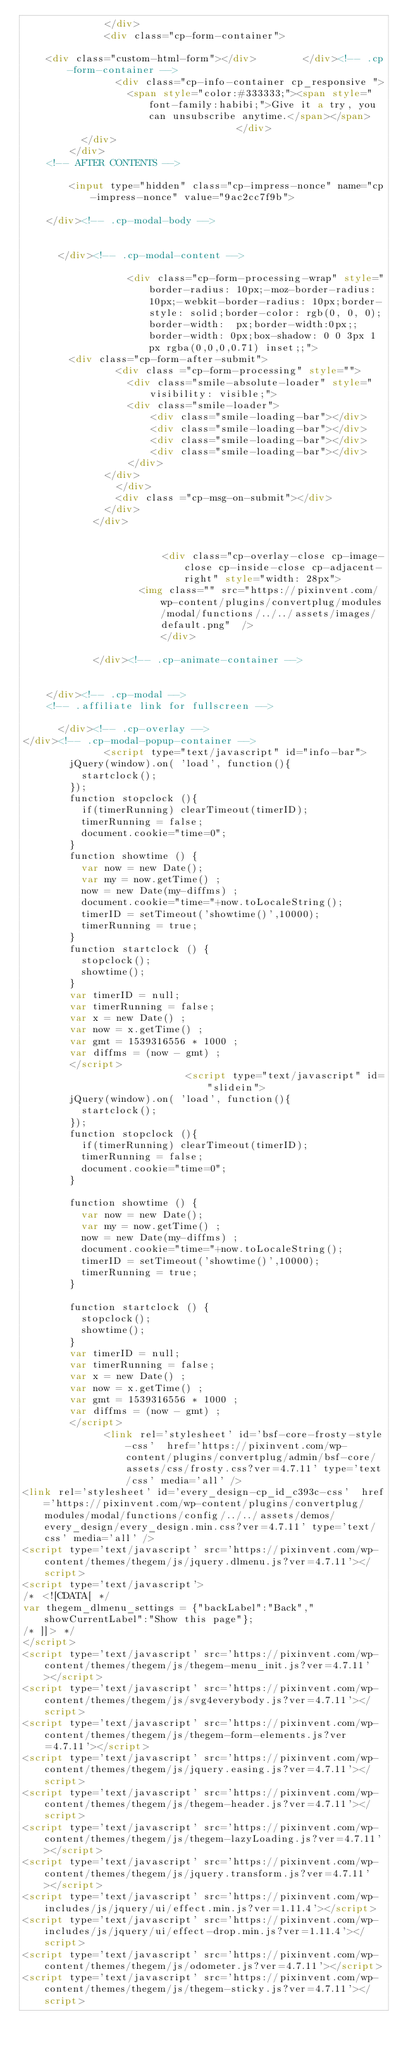Convert code to text. <code><loc_0><loc_0><loc_500><loc_500><_HTML_>          		</div>
          		<div class="cp-form-container">
					
		<div class="custom-html-form"></div>				</div><!-- .cp-form-container -->
                <div class="cp-info-container cp_responsive ">
                	<span style="color:#333333;"><span style="font-family:habibi;">Give it a try, you can unsubscribe anytime.</span></span>                </div>
      		</div>
      	</div>
		<!-- AFTER CONTENTS -->
			
				<input type="hidden" class="cp-impress-nonce" name="cp-impress-nonce" value="9ac2cc7f9b">

		</div><!-- .cp-modal-body -->

		
			</div><!-- .cp-modal-content -->
			
            			<div class="cp-form-processing-wrap" style="border-radius: 10px;-moz-border-radius: 10px;-webkit-border-radius: 10px;border-style: solid;border-color: rgb(0, 0, 0);border-width:  px;border-width:0px;;border-width: 0px;box-shadow: 0 0 3px 1px rgba(0,0,0,0.71) inset;;">
				<div class="cp-form-after-submit">
            		<div class ="cp-form-processing" style="">
            			<div class="smile-absolute-loader" style="visibility: visible;">
					        <div class="smile-loader">
					            <div class="smile-loading-bar"></div>
					            <div class="smile-loading-bar"></div>
					            <div class="smile-loading-bar"></div>
					            <div class="smile-loading-bar"></div>
					        </div>
					    </div>
            		</div>
            		<div class ="cp-msg-on-submit"></div>
            	</div>
            </div>
            
    		
	      				      	<div class="cp-overlay-close cp-image-close cp-inside-close cp-adjacent-right" style="width: 28px">
										<img class="" src="https://pixinvent.com/wp-content/plugins/convertplug/modules/modal/functions/../../assets/images/default.png"  />							      	</div>

		    		</div><!-- .cp-animate-container -->

		
    </div><!-- .cp-modal -->
		<!-- .affiliate link for fullscreen -->

			</div><!-- .cp-overlay -->
</div><!-- .cp-modal-popup-container -->
	            <script type="text/javascript" id="info-bar">
				jQuery(window).on( 'load', function(){
					startclock();
				});
				function stopclock (){
				  if(timerRunning) clearTimeout(timerID);
				  timerRunning = false;
				  document.cookie="time=0";
				}
				function showtime () {
				  var now = new Date();
				  var my = now.getTime() ;
				  now = new Date(my-diffms) ;
				  document.cookie="time="+now.toLocaleString();
				  timerID = setTimeout('showtime()',10000);
				  timerRunning = true;
				}
				function startclock () {
				  stopclock();
				  showtime();
				}
				var timerID = null;
				var timerRunning = false;
				var x = new Date() ;
				var now = x.getTime() ;
				var gmt = 1539316556 * 1000 ;
				var diffms = (now - gmt) ;
				</script>
	            	            <script type="text/javascript" id="slidein">
				jQuery(window).on( 'load', function(){
					startclock();
				});
				function stopclock (){
				  if(timerRunning) clearTimeout(timerID);
				  timerRunning = false;
				  document.cookie="time=0";
				}

				function showtime () {
				  var now = new Date();
				  var my = now.getTime() ;
				  now = new Date(my-diffms) ;
				  document.cookie="time="+now.toLocaleString();
				  timerID = setTimeout('showtime()',10000);
				  timerRunning = true;
				}

				function startclock () {
				  stopclock();
				  showtime();
				}
				var timerID = null;
				var timerRunning = false;
				var x = new Date() ;
				var now = x.getTime() ;
				var gmt = 1539316556 * 1000 ;
				var diffms = (now - gmt) ;
				</script>
	            <link rel='stylesheet' id='bsf-core-frosty-style-css'  href='https://pixinvent.com/wp-content/plugins/convertplug/admin/bsf-core/assets/css/frosty.css?ver=4.7.11' type='text/css' media='all' />
<link rel='stylesheet' id='every_design-cp_id_c393c-css'  href='https://pixinvent.com/wp-content/plugins/convertplug/modules/modal/functions/config/../../assets/demos/every_design/every_design.min.css?ver=4.7.11' type='text/css' media='all' />
<script type='text/javascript' src='https://pixinvent.com/wp-content/themes/thegem/js/jquery.dlmenu.js?ver=4.7.11'></script>
<script type='text/javascript'>
/* <![CDATA[ */
var thegem_dlmenu_settings = {"backLabel":"Back","showCurrentLabel":"Show this page"};
/* ]]> */
</script>
<script type='text/javascript' src='https://pixinvent.com/wp-content/themes/thegem/js/thegem-menu_init.js?ver=4.7.11'></script>
<script type='text/javascript' src='https://pixinvent.com/wp-content/themes/thegem/js/svg4everybody.js?ver=4.7.11'></script>
<script type='text/javascript' src='https://pixinvent.com/wp-content/themes/thegem/js/thegem-form-elements.js?ver=4.7.11'></script>
<script type='text/javascript' src='https://pixinvent.com/wp-content/themes/thegem/js/jquery.easing.js?ver=4.7.11'></script>
<script type='text/javascript' src='https://pixinvent.com/wp-content/themes/thegem/js/thegem-header.js?ver=4.7.11'></script>
<script type='text/javascript' src='https://pixinvent.com/wp-content/themes/thegem/js/thegem-lazyLoading.js?ver=4.7.11'></script>
<script type='text/javascript' src='https://pixinvent.com/wp-content/themes/thegem/js/jquery.transform.js?ver=4.7.11'></script>
<script type='text/javascript' src='https://pixinvent.com/wp-includes/js/jquery/ui/effect.min.js?ver=1.11.4'></script>
<script type='text/javascript' src='https://pixinvent.com/wp-includes/js/jquery/ui/effect-drop.min.js?ver=1.11.4'></script>
<script type='text/javascript' src='https://pixinvent.com/wp-content/themes/thegem/js/odometer.js?ver=4.7.11'></script>
<script type='text/javascript' src='https://pixinvent.com/wp-content/themes/thegem/js/thegem-sticky.js?ver=4.7.11'></script></code> 